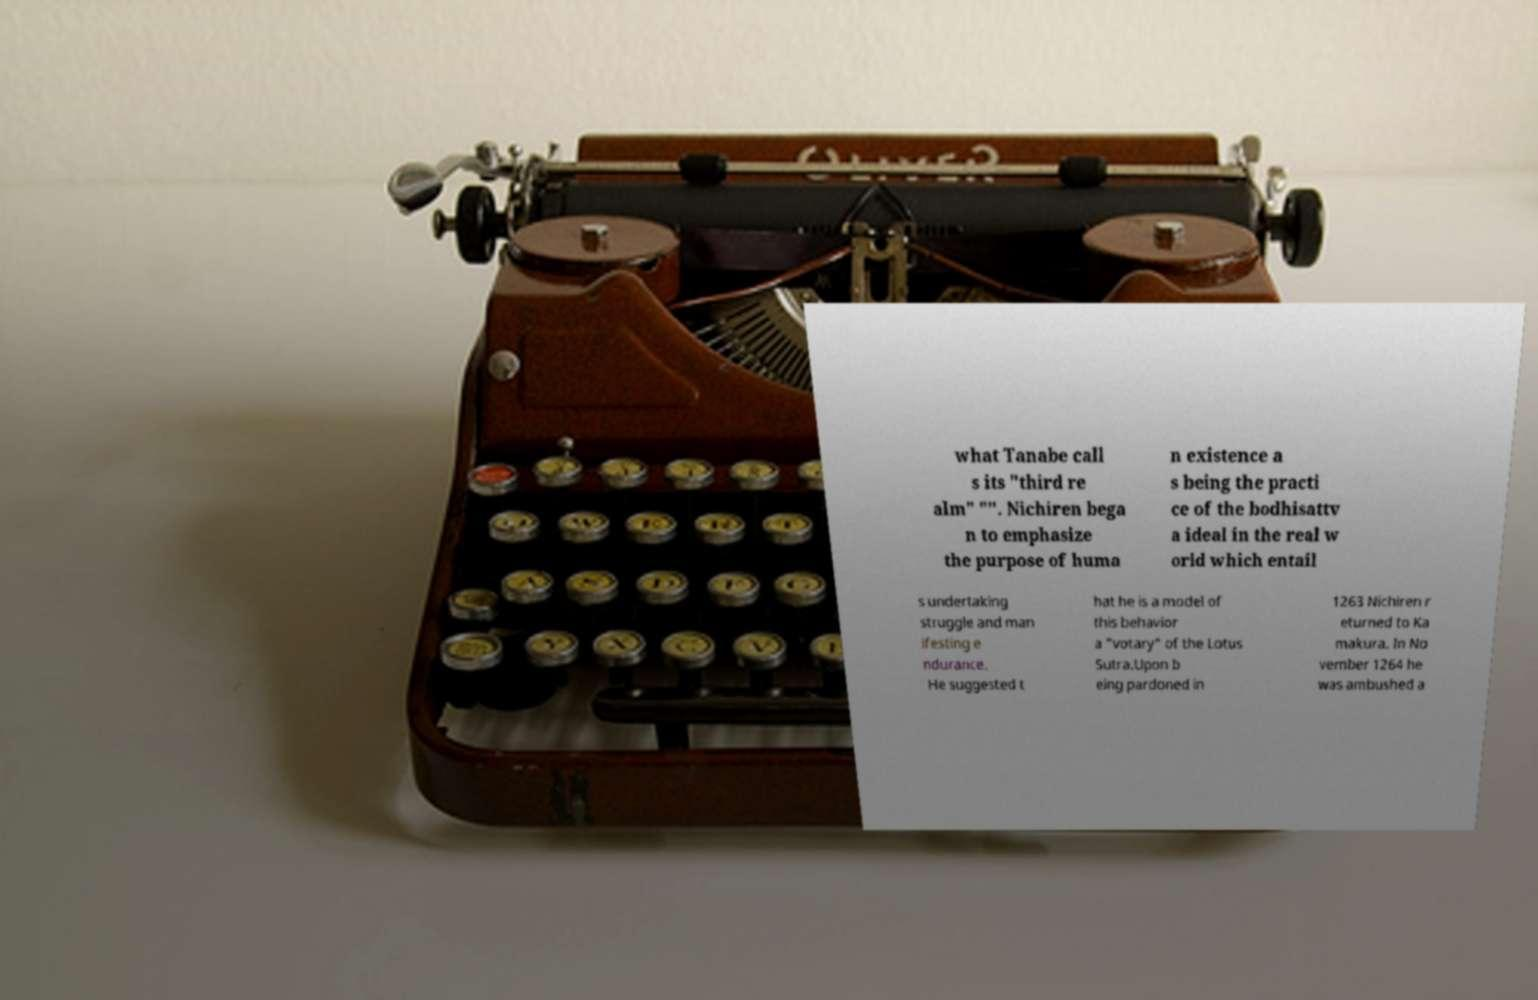Could you extract and type out the text from this image? what Tanabe call s its "third re alm" "". Nichiren bega n to emphasize the purpose of huma n existence a s being the practi ce of the bodhisattv a ideal in the real w orld which entail s undertaking struggle and man ifesting e ndurance. He suggested t hat he is a model of this behavior a "votary" of the Lotus Sutra.Upon b eing pardoned in 1263 Nichiren r eturned to Ka makura. In No vember 1264 he was ambushed a 